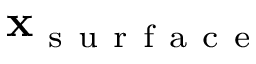<formula> <loc_0><loc_0><loc_500><loc_500>\mathbf x _ { s u r f a c e }</formula> 